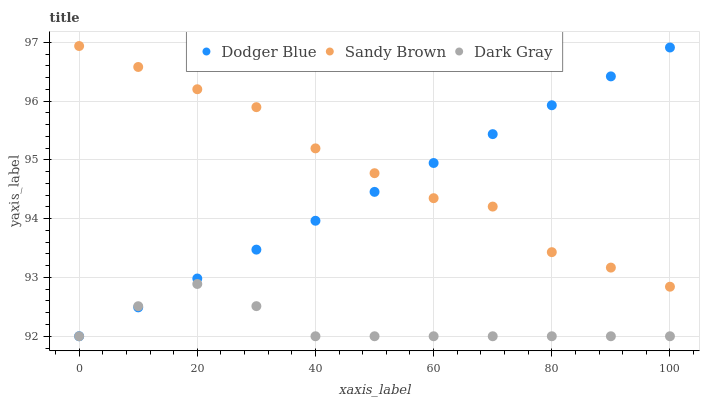Does Dark Gray have the minimum area under the curve?
Answer yes or no. Yes. Does Sandy Brown have the maximum area under the curve?
Answer yes or no. Yes. Does Dodger Blue have the minimum area under the curve?
Answer yes or no. No. Does Dodger Blue have the maximum area under the curve?
Answer yes or no. No. Is Dodger Blue the smoothest?
Answer yes or no. Yes. Is Sandy Brown the roughest?
Answer yes or no. Yes. Is Sandy Brown the smoothest?
Answer yes or no. No. Is Dodger Blue the roughest?
Answer yes or no. No. Does Dark Gray have the lowest value?
Answer yes or no. Yes. Does Sandy Brown have the lowest value?
Answer yes or no. No. Does Sandy Brown have the highest value?
Answer yes or no. Yes. Does Dodger Blue have the highest value?
Answer yes or no. No. Is Dark Gray less than Sandy Brown?
Answer yes or no. Yes. Is Sandy Brown greater than Dark Gray?
Answer yes or no. Yes. Does Sandy Brown intersect Dodger Blue?
Answer yes or no. Yes. Is Sandy Brown less than Dodger Blue?
Answer yes or no. No. Is Sandy Brown greater than Dodger Blue?
Answer yes or no. No. Does Dark Gray intersect Sandy Brown?
Answer yes or no. No. 